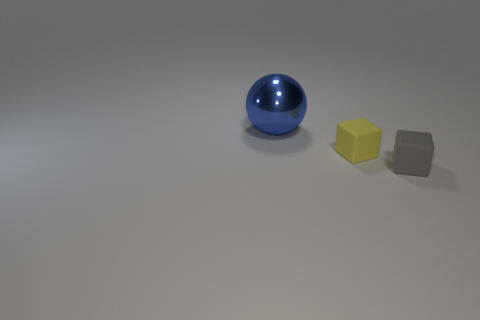Add 2 brown matte spheres. How many objects exist? 5 Subtract 0 green blocks. How many objects are left? 3 Subtract all balls. How many objects are left? 2 Subtract all large brown rubber things. Subtract all tiny cubes. How many objects are left? 1 Add 3 small cubes. How many small cubes are left? 5 Add 3 gray metal cylinders. How many gray metal cylinders exist? 3 